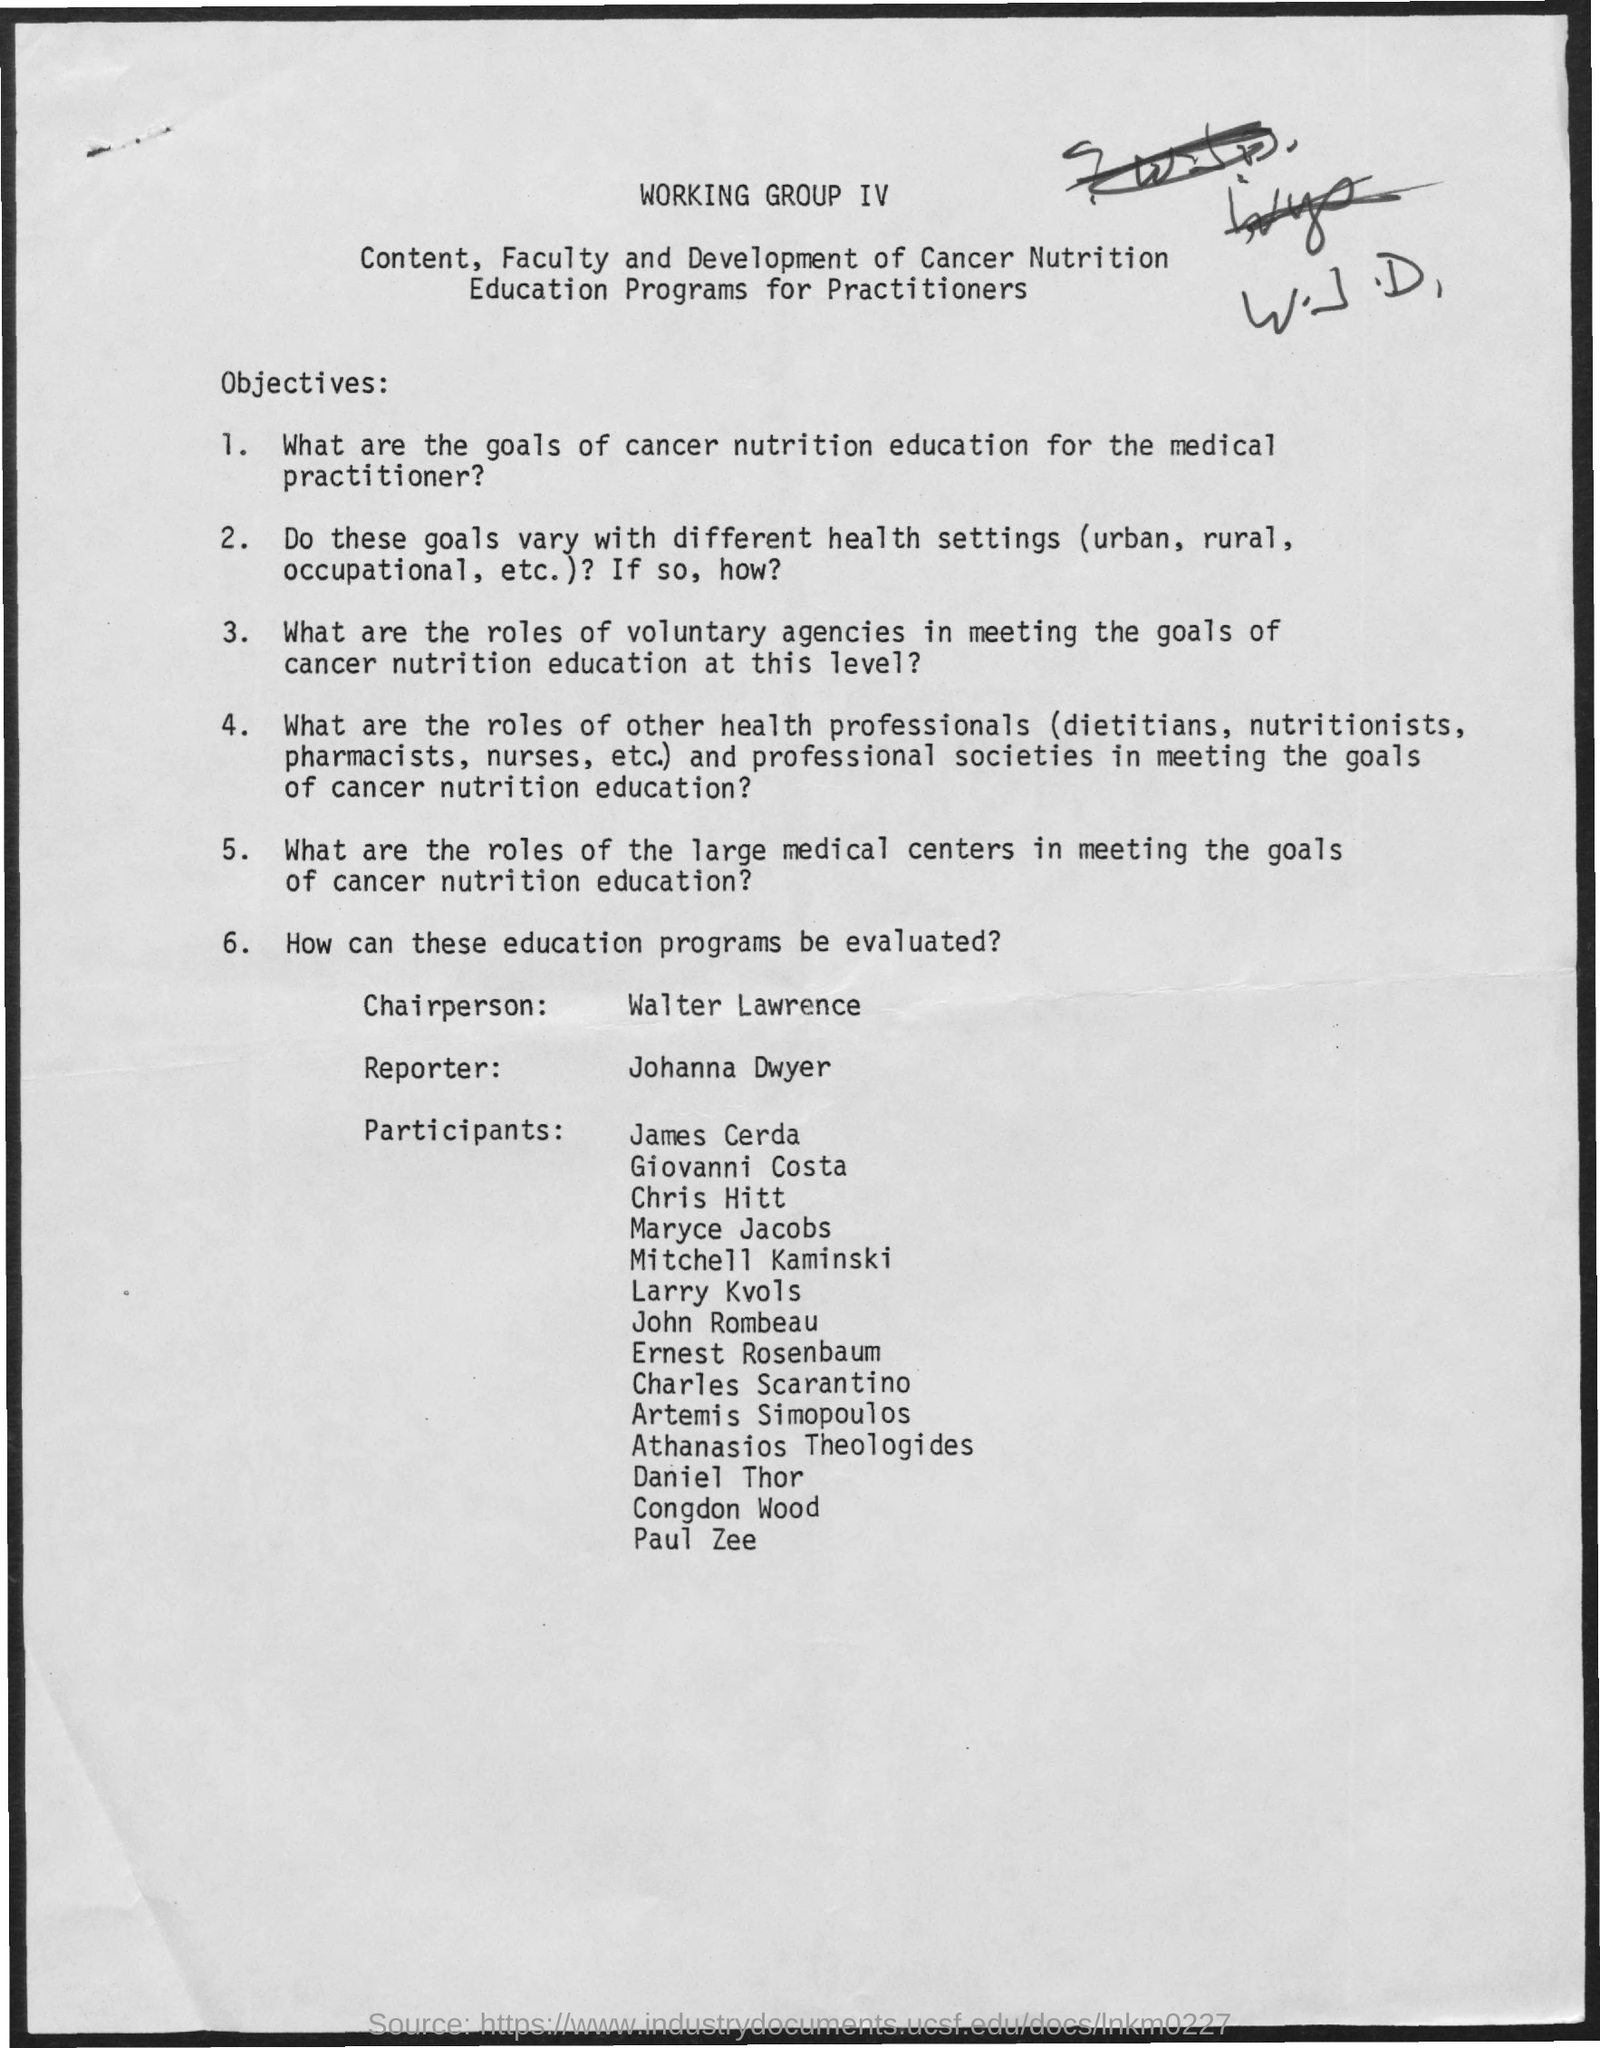Who is the chairperson for the education programs?
Give a very brief answer. WALTER LAWRENCE. What is the reporter name mentioned in the document?
Provide a succinct answer. JOHANNA DWYER. 